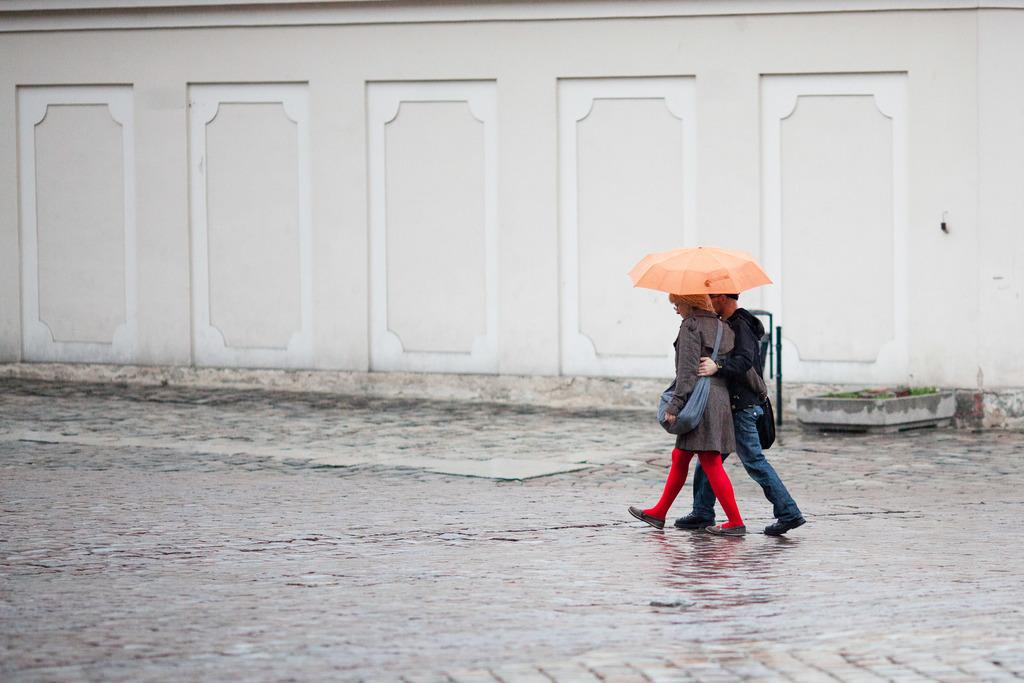How many people are in the image? There are two people in the image. What are the two people doing in the image? The two people are walking. What are the two people holding in the image? The two people are holding an umbrella. What can be seen in the background of the image? There is a wall visible in the background of the image. What type of wrench can be seen in the image? There is no wrench present in the image. What is the distance between the two people in the image? The provided facts do not give information about the distance between the two people, so it cannot be determined from the image. 